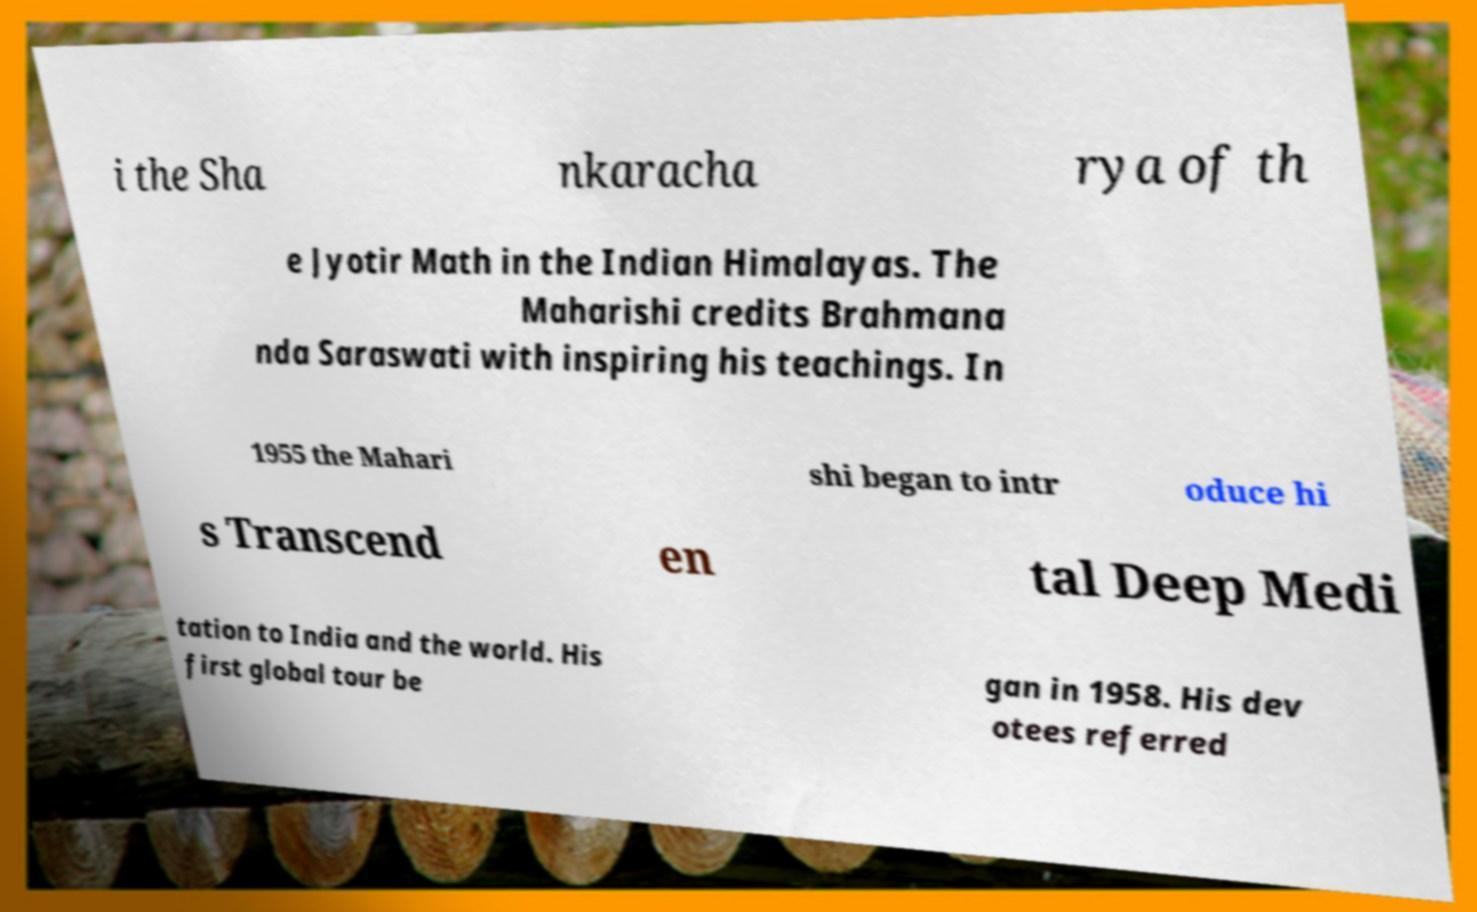Could you assist in decoding the text presented in this image and type it out clearly? i the Sha nkaracha rya of th e Jyotir Math in the Indian Himalayas. The Maharishi credits Brahmana nda Saraswati with inspiring his teachings. In 1955 the Mahari shi began to intr oduce hi s Transcend en tal Deep Medi tation to India and the world. His first global tour be gan in 1958. His dev otees referred 